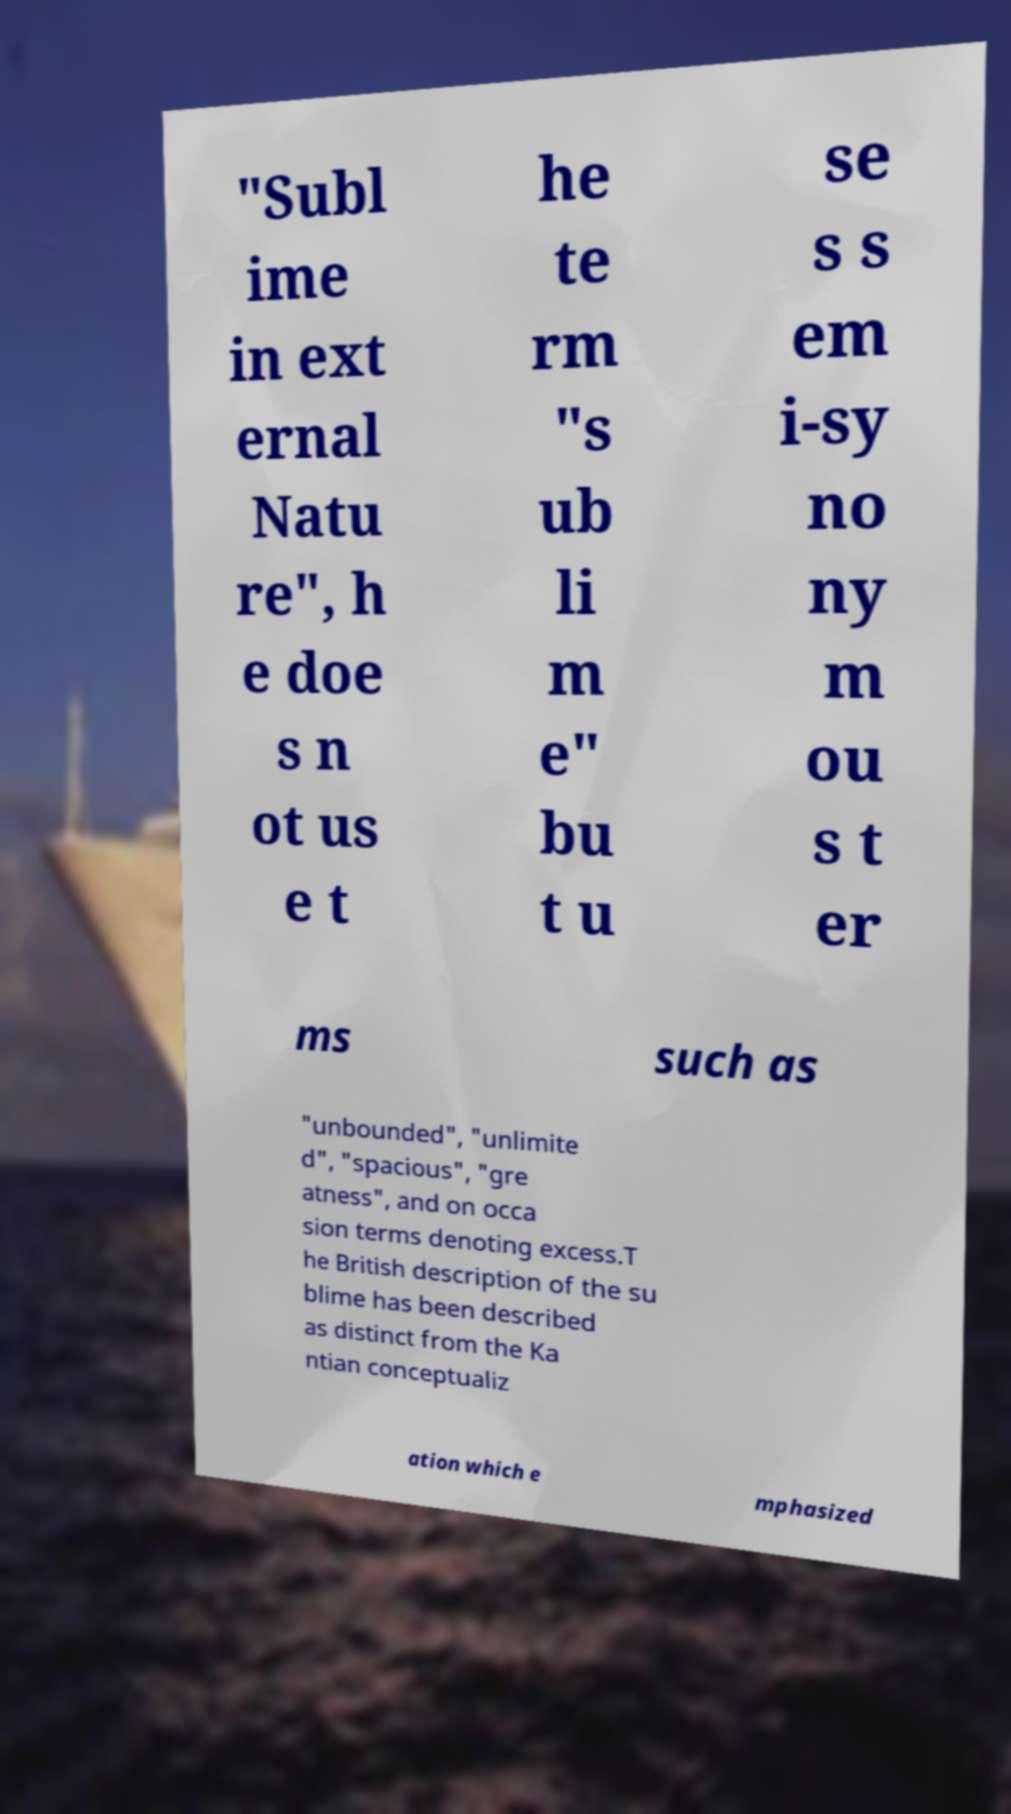Could you assist in decoding the text presented in this image and type it out clearly? "Subl ime in ext ernal Natu re", h e doe s n ot us e t he te rm "s ub li m e" bu t u se s s em i-sy no ny m ou s t er ms such as "unbounded", "unlimite d", "spacious", "gre atness", and on occa sion terms denoting excess.T he British description of the su blime has been described as distinct from the Ka ntian conceptualiz ation which e mphasized 